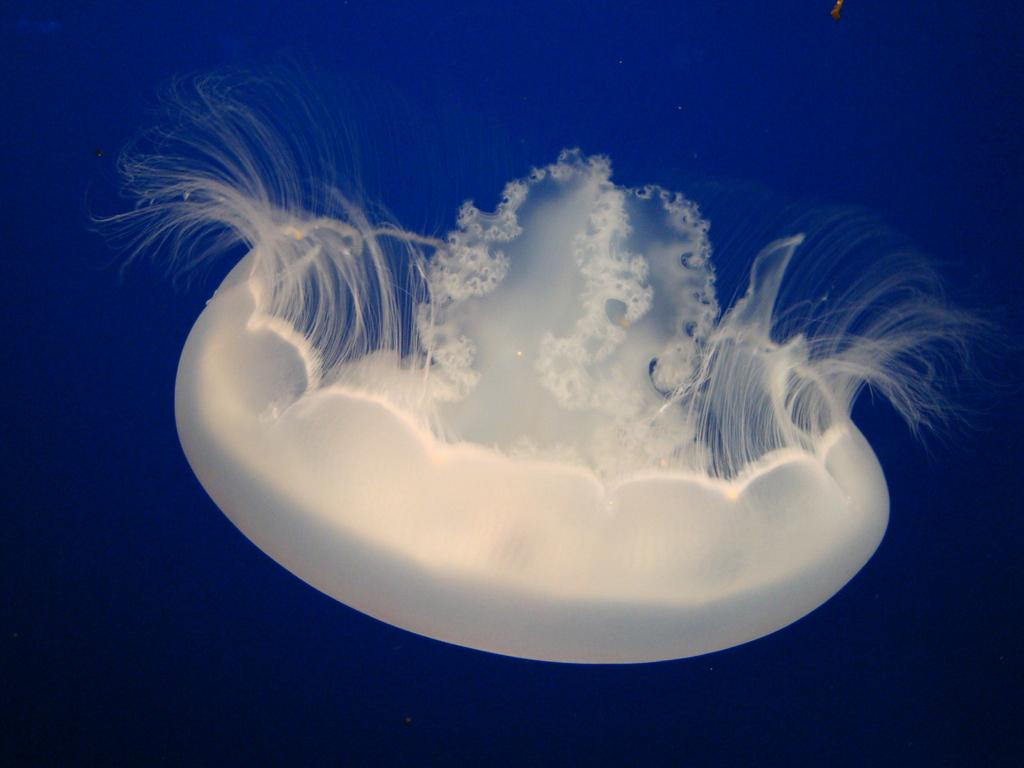What type of animal is in the image? There is a white color jellyfish in the image. Where is the jellyfish located? The jellyfish is in the water. What color is the background of the image? The background of the image is blue in color. How many ants can be seen crawling on the jellyfish in the image? There are no ants present in the image; it features a white color jellyfish in the water. What type of vegetable is visible in the image? There is no vegetable present in the image; it features a white color jellyfish in the water. 